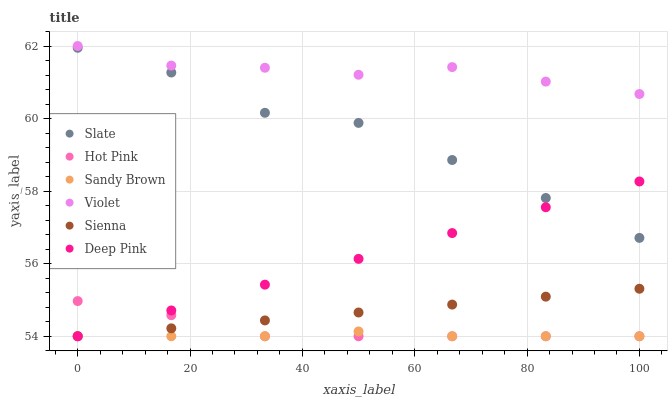Does Sandy Brown have the minimum area under the curve?
Answer yes or no. Yes. Does Violet have the maximum area under the curve?
Answer yes or no. Yes. Does Slate have the minimum area under the curve?
Answer yes or no. No. Does Slate have the maximum area under the curve?
Answer yes or no. No. Is Deep Pink the smoothest?
Answer yes or no. Yes. Is Slate the roughest?
Answer yes or no. Yes. Is Hot Pink the smoothest?
Answer yes or no. No. Is Hot Pink the roughest?
Answer yes or no. No. Does Deep Pink have the lowest value?
Answer yes or no. Yes. Does Slate have the lowest value?
Answer yes or no. No. Does Violet have the highest value?
Answer yes or no. Yes. Does Slate have the highest value?
Answer yes or no. No. Is Sandy Brown less than Violet?
Answer yes or no. Yes. Is Violet greater than Deep Pink?
Answer yes or no. Yes. Does Sienna intersect Hot Pink?
Answer yes or no. Yes. Is Sienna less than Hot Pink?
Answer yes or no. No. Is Sienna greater than Hot Pink?
Answer yes or no. No. Does Sandy Brown intersect Violet?
Answer yes or no. No. 